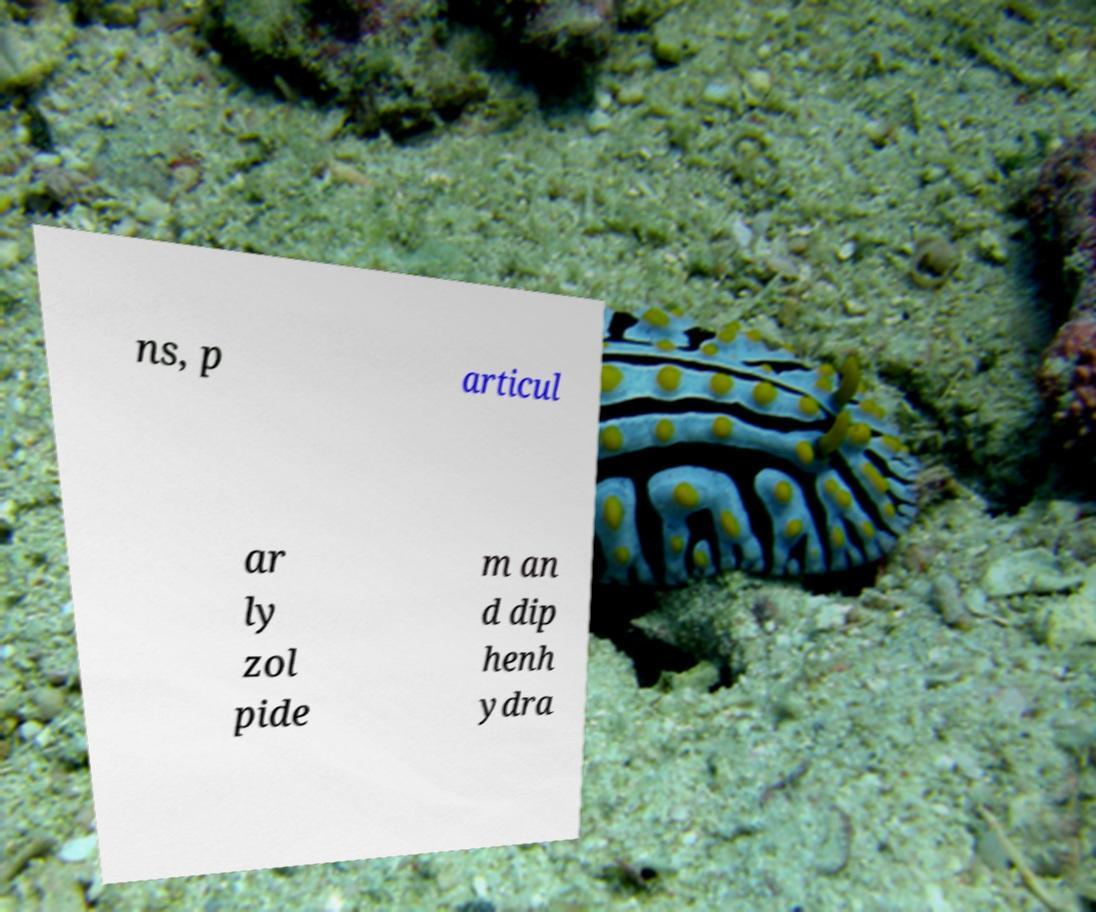Can you accurately transcribe the text from the provided image for me? ns, p articul ar ly zol pide m an d dip henh ydra 